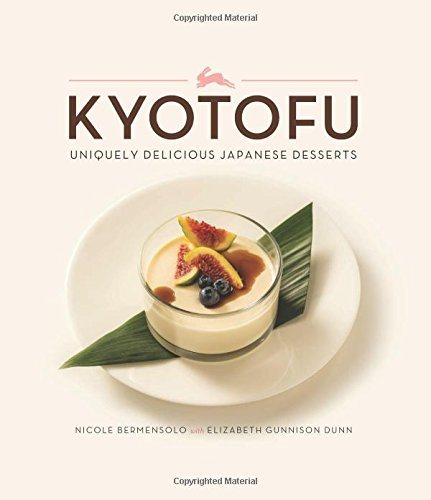What makes Japanese desserts unique according to this book? This book emphasizes the uniqueness of Japanese desserts through their aesthetics and the balance of flavors. It highlights how traditional ingredients like matcha, sesame, and yuzu are used in innovative ways to foster both taste and visual appeal in desserts. 